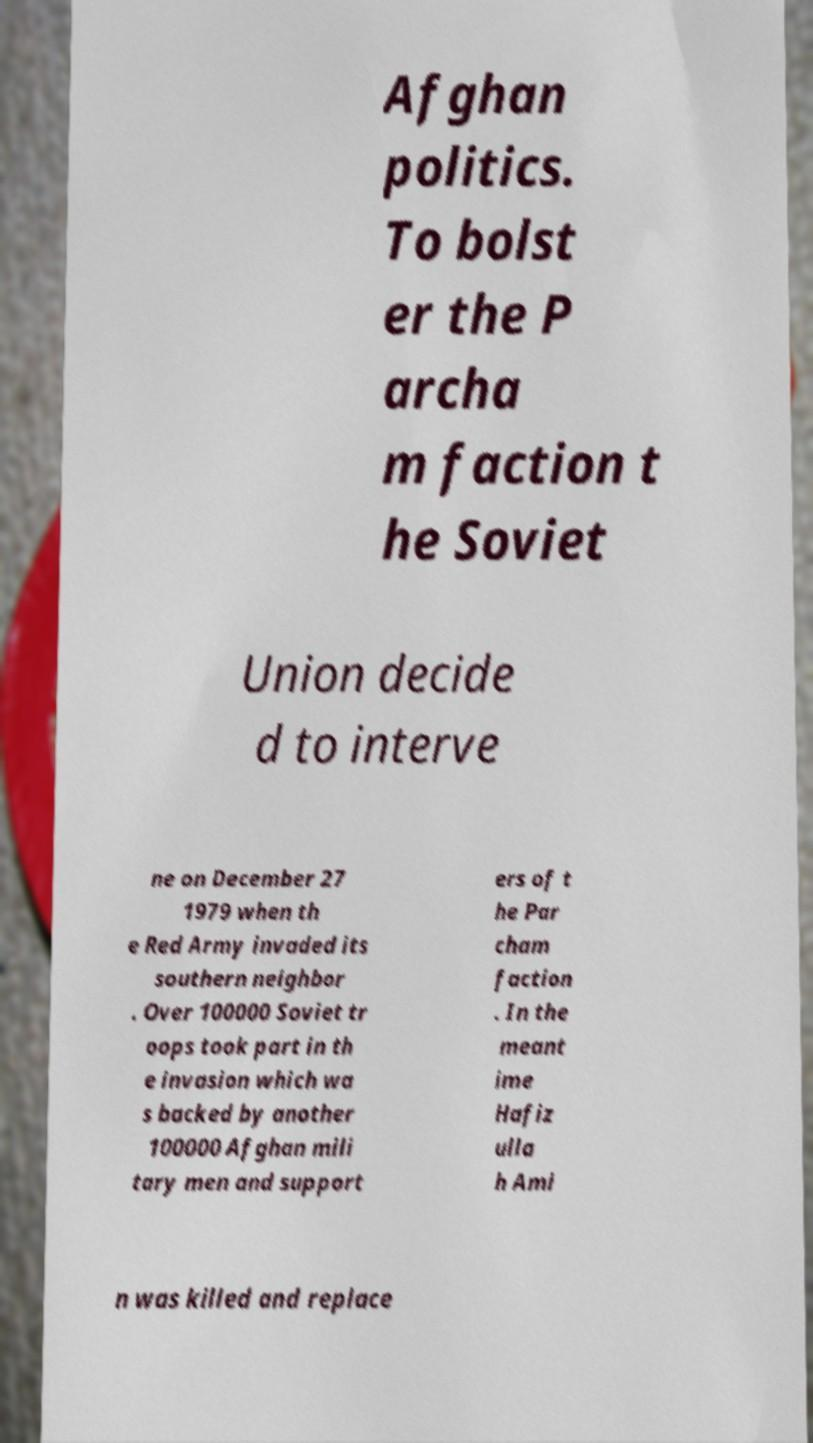Could you assist in decoding the text presented in this image and type it out clearly? Afghan politics. To bolst er the P archa m faction t he Soviet Union decide d to interve ne on December 27 1979 when th e Red Army invaded its southern neighbor . Over 100000 Soviet tr oops took part in th e invasion which wa s backed by another 100000 Afghan mili tary men and support ers of t he Par cham faction . In the meant ime Hafiz ulla h Ami n was killed and replace 